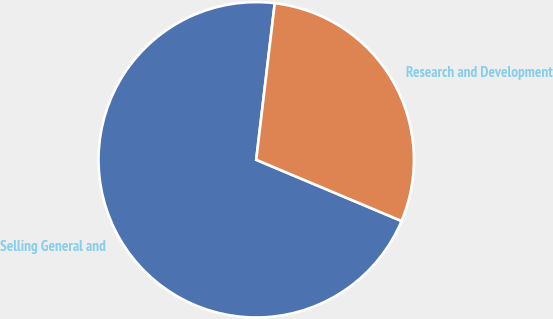Convert chart. <chart><loc_0><loc_0><loc_500><loc_500><pie_chart><fcel>Selling General and<fcel>Research and Development<nl><fcel>70.53%<fcel>29.47%<nl></chart> 